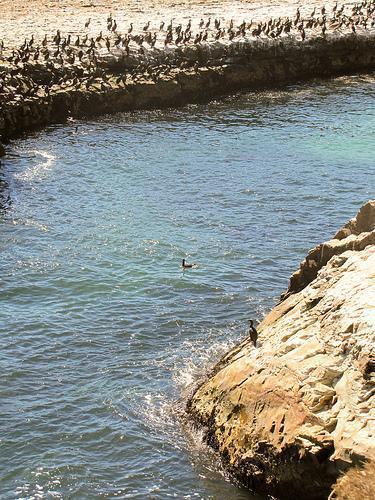How many birds in the water?
Give a very brief answer. 1. 